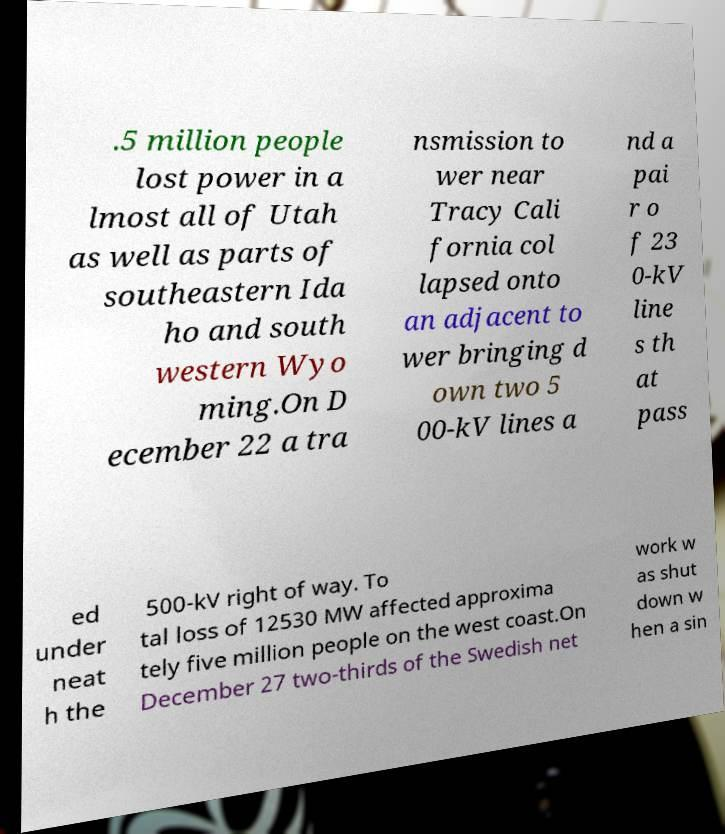Could you assist in decoding the text presented in this image and type it out clearly? .5 million people lost power in a lmost all of Utah as well as parts of southeastern Ida ho and south western Wyo ming.On D ecember 22 a tra nsmission to wer near Tracy Cali fornia col lapsed onto an adjacent to wer bringing d own two 5 00-kV lines a nd a pai r o f 23 0-kV line s th at pass ed under neat h the 500-kV right of way. To tal loss of 12530 MW affected approxima tely five million people on the west coast.On December 27 two-thirds of the Swedish net work w as shut down w hen a sin 